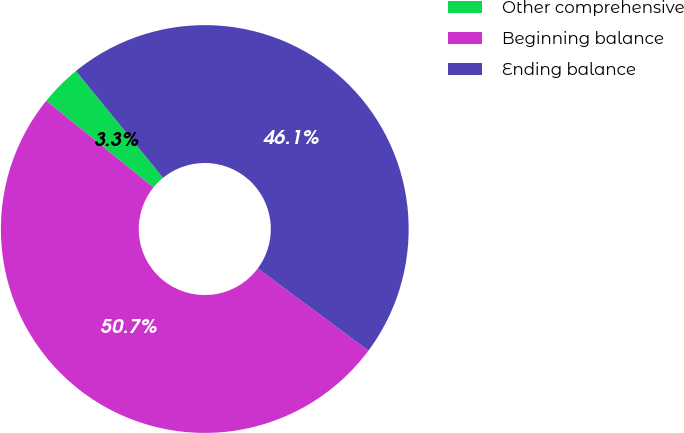Convert chart. <chart><loc_0><loc_0><loc_500><loc_500><pie_chart><fcel>Other comprehensive<fcel>Beginning balance<fcel>Ending balance<nl><fcel>3.28%<fcel>50.66%<fcel>46.06%<nl></chart> 